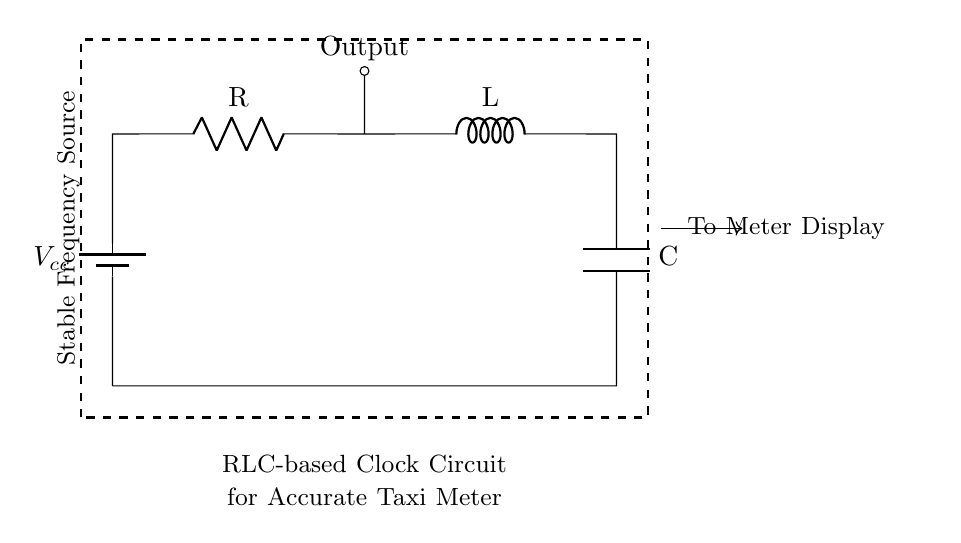What components are in the circuit? The circuit includes a battery, a resistor, an inductor, and a capacitor. These are clearly labeled in the diagram.
Answer: battery, resistor, inductor, capacitor What is the function of the battery in this circuit? The battery provides the voltage supply for the circuit, essential for energizing the components.
Answer: Voltage supply What is connected to the output? The output is directly connected to a stable frequency source, which accounts for the timing mechanism essential for the taxi meter.
Answer: Stable frequency source How do the RLC components affect the frequency of the circuit? The resistor, inductor, and capacitor together determine the oscillation frequency of the circuit through their combined reactance and resistance, thus stabilizing the clock signal required for accuracy in the taxi meter.
Answer: They determine frequency What role does the capacitor play in this RLC circuit? The capacitor stores energy and affects the timing characteristics of the circuit, influencing the oscillation and thus the accuracy of the clock signal for the taxi meter.
Answer: Stores energy What type of circuit is represented here? This is an RLC circuit, which consists of a resistor, inductor, and capacitor in series configuration. This specific design is tailored for timing applications.
Answer: RLC circuit 